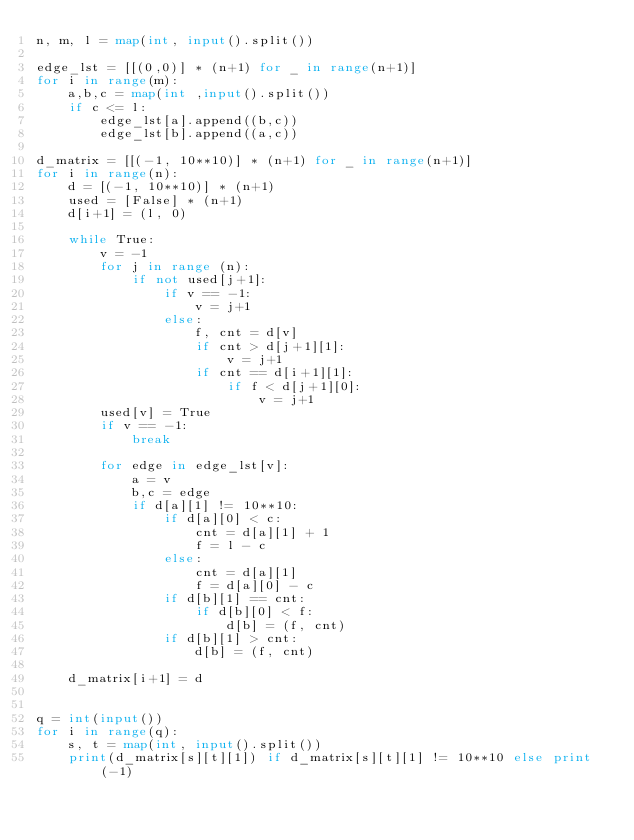Convert code to text. <code><loc_0><loc_0><loc_500><loc_500><_Python_>n, m, l = map(int, input().split())

edge_lst = [[(0,0)] * (n+1) for _ in range(n+1)]
for i in range(m):
    a,b,c = map(int ,input().split())
    if c <= l:
        edge_lst[a].append((b,c))
        edge_lst[b].append((a,c))
        
d_matrix = [[(-1, 10**10)] * (n+1) for _ in range(n+1)]
for i in range(n):
    d = [(-1, 10**10)] * (n+1)
    used = [False] * (n+1)
    d[i+1] = (l, 0)
    
    while True:
        v = -1
        for j in range (n):
            if not used[j+1]:
                if v == -1:
                    v = j+1
                else:
                    f, cnt = d[v]
                    if cnt > d[j+1][1]:
                        v = j+1
                    if cnt == d[i+1][1]:
                        if f < d[j+1][0]:
                            v = j+1    
        used[v] = True
        if v == -1:
            break

        for edge in edge_lst[v]:
            a = v
            b,c = edge
            if d[a][1] != 10**10:
                if d[a][0] < c:
                    cnt = d[a][1] + 1
                    f = l - c
                else:
                    cnt = d[a][1]
                    f = d[a][0] - c
                if d[b][1] == cnt:
                    if d[b][0] < f:
                        d[b] = (f, cnt)
                if d[b][1] > cnt:
                    d[b] = (f, cnt)
    
    d_matrix[i+1] = d
            

q = int(input())
for i in range(q):
    s, t = map(int, input().split())
    print(d_matrix[s][t][1]) if d_matrix[s][t][1] != 10**10 else print(-1)</code> 